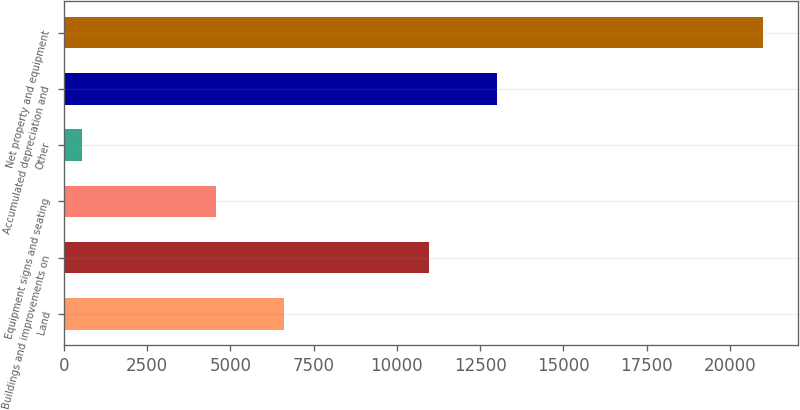<chart> <loc_0><loc_0><loc_500><loc_500><bar_chart><fcel>Land<fcel>Buildings and improvements on<fcel>Equipment signs and seating<fcel>Other<fcel>Accumulated depreciation and<fcel>Net property and equipment<nl><fcel>6602.7<fcel>10962.6<fcel>4558.2<fcel>539.7<fcel>13007.1<fcel>20984.7<nl></chart> 